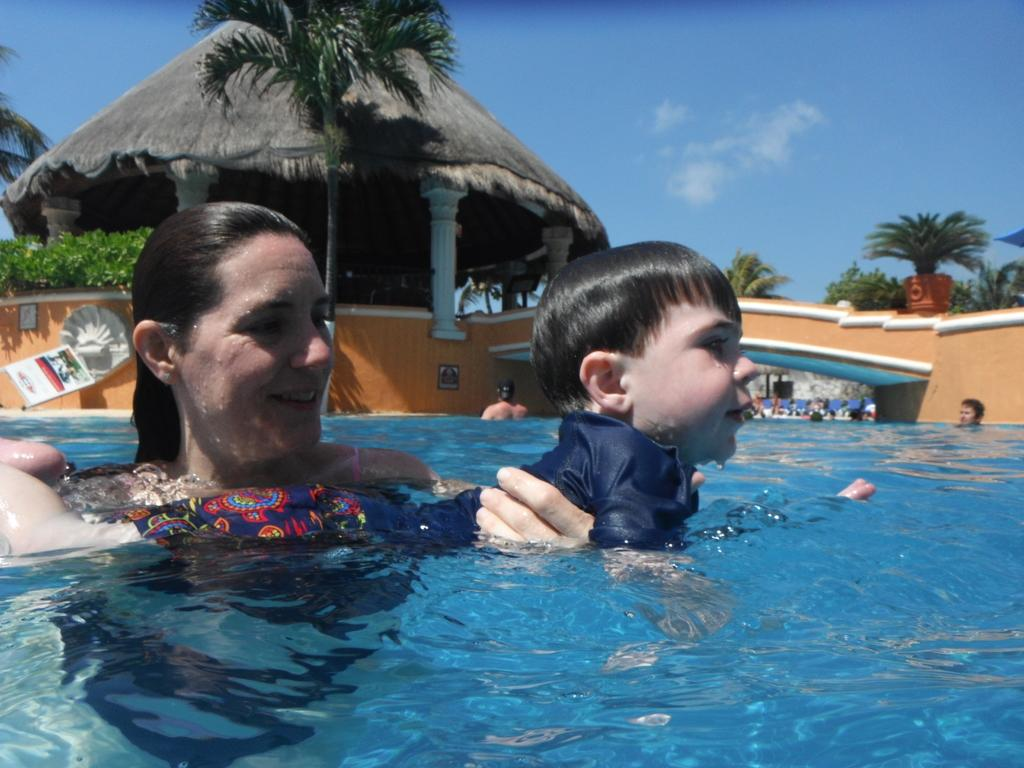Who is the main subject in the image? There is a woman in the image. What is the woman doing in the image? The woman is holding a boy and swimming in a pool. What can be seen in the background of the image? There is a wall, trees, and a hut in the background of the image. What is visible at the top of the image? The sky is visible at the top of the image. Can you tell me how many squirrels are playing tricks with the liquid in the image? There are no squirrels or liquid present in the image. What type of trick is the woman performing on the boy in the image? The image does not depict any tricks being performed; the woman is simply holding the boy while swimming in a pool. 